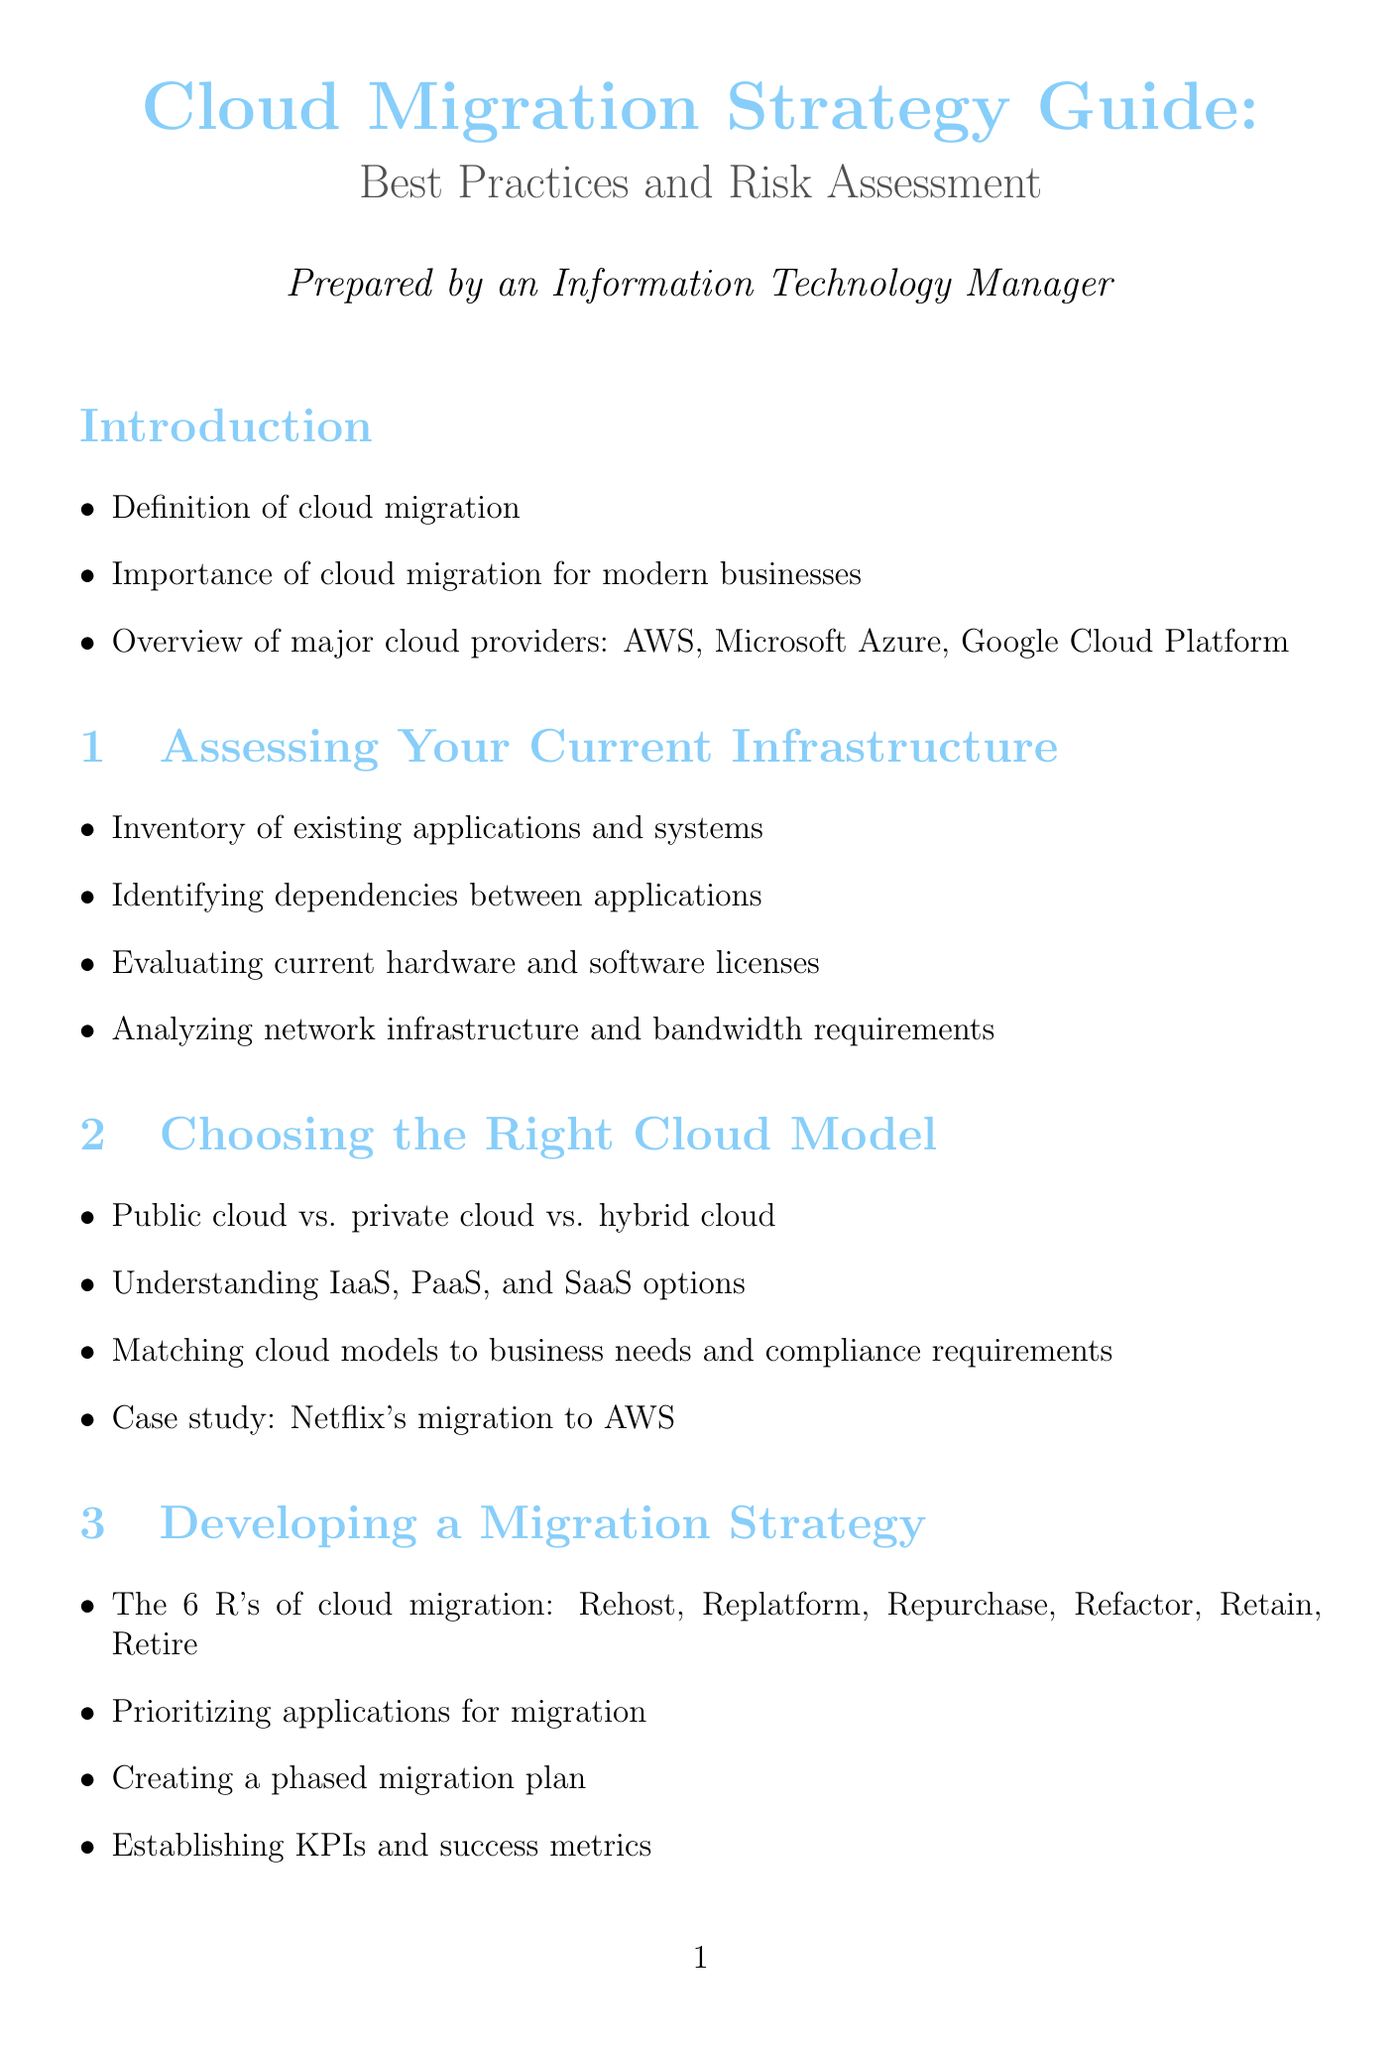what are the major cloud providers mentioned? The document lists AWS, Microsoft Azure, and Google Cloud Platform as the major cloud providers.
Answer: AWS, Microsoft Azure, Google Cloud Platform what are the 6 R's of cloud migration? The 6 R's of cloud migration are Rehost, Replatform, Repurchase, Refactor, Retain, and Retire.
Answer: Rehost, Replatform, Repurchase, Refactor, Retain, Retire which cloud pricing models are discussed? The document discusses the understanding of cloud pricing models as part of cost management.
Answer: cloud pricing models what are some risks identified in the risk assessment section? The document mentions data loss, downtime, and compliance issues as potential risks.
Answer: data loss, downtime, compliance issues what are the training topics suggested for skill development? The document suggests providing cloud certification training, such as AWS Certified Solutions Architect and Microsoft Azure Administrator.
Answer: AWS Certified Solutions Architect, Microsoft Azure Administrator which automation tools are recommended for cloud migration? The document recommends leveraging automation tools like Terraform and Ansible during migration.
Answer: Terraform, Ansible how is performance managed in the cloud according to the document? The document outlines implementing cloud monitoring tools and conducting regular performance reviews and optimizations as means to manage performance.
Answer: cloud monitoring tools, regular performance reviews which case study is mentioned regarding migration to AWS? The document mentions Capital One's migration to AWS as a case study.
Answer: Capital One's migration to AWS 